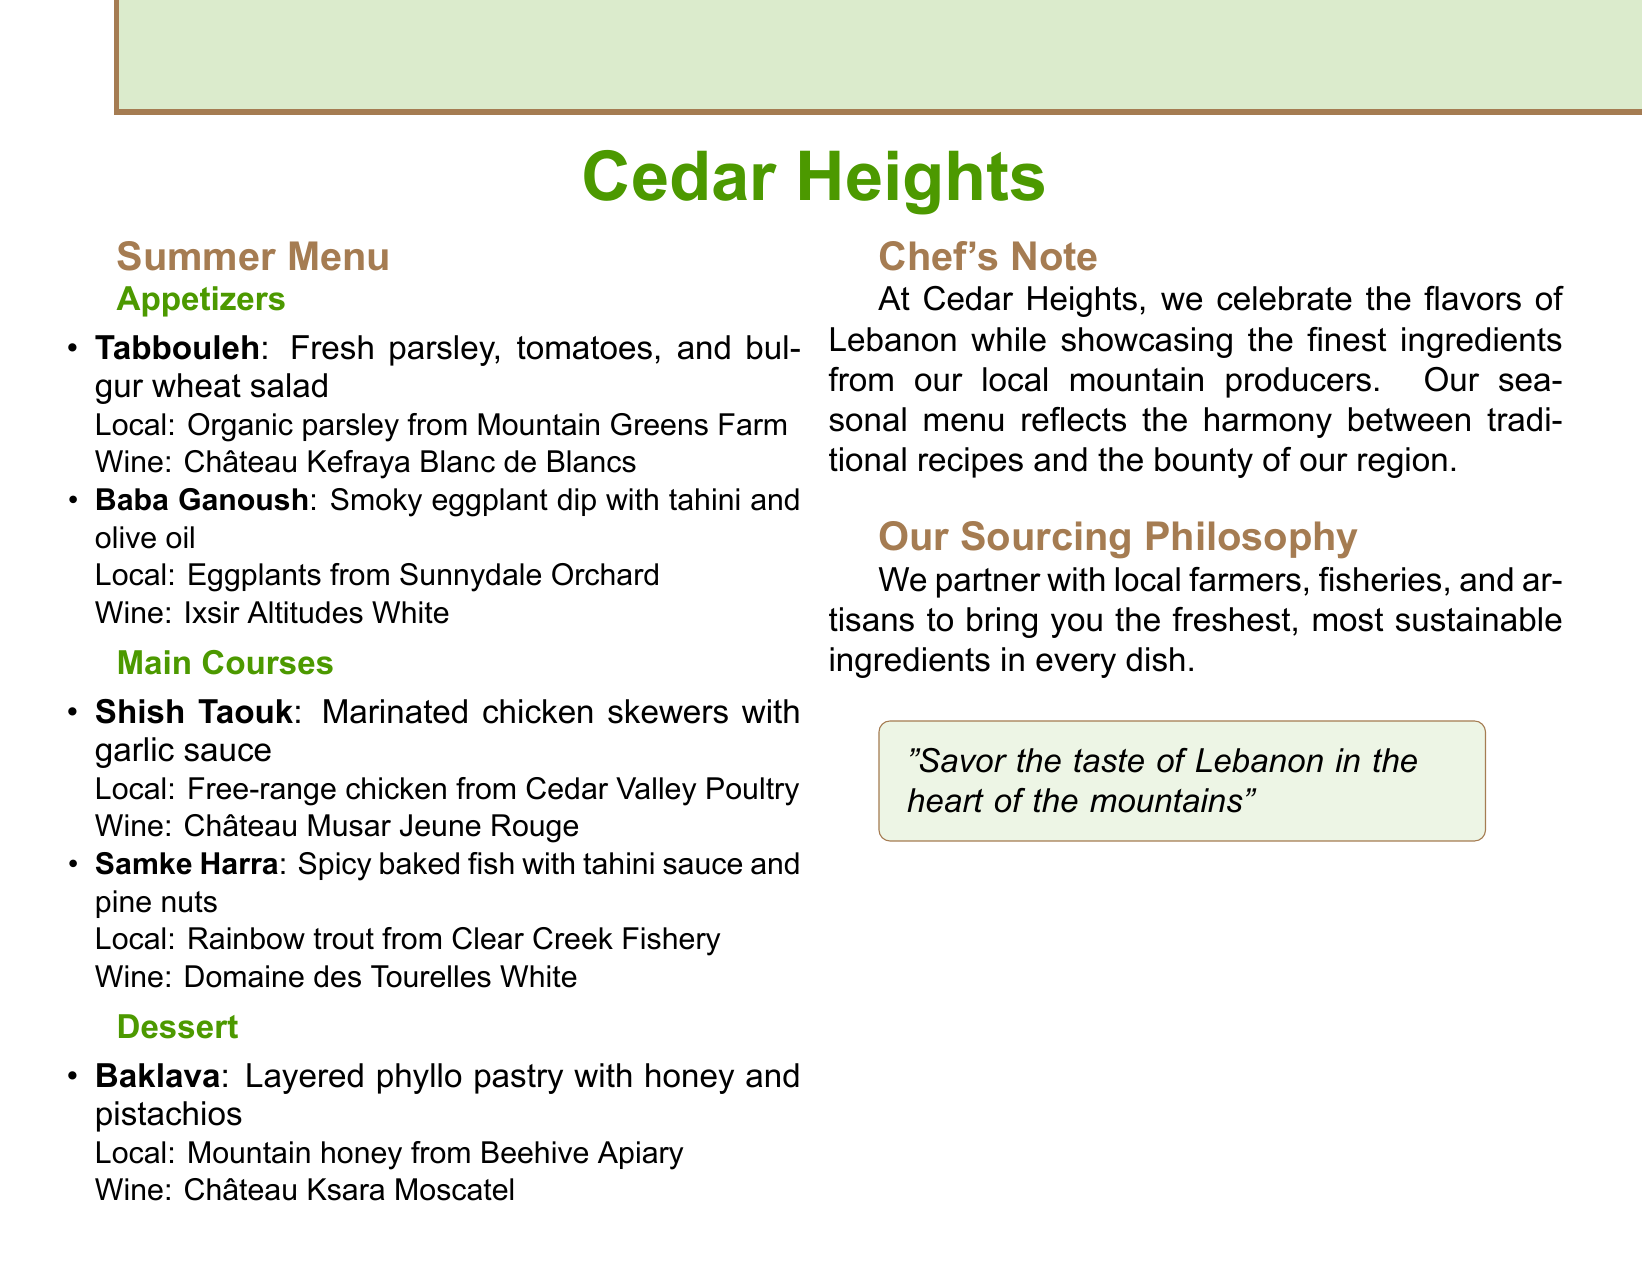what is the name of the restaurant? The name of the restaurant is stated prominently at the top of the document.
Answer: Cedar Heights what type of cuisine is featured in the menu? The document specifies the type of cuisine prominently in the title.
Answer: Lebanese which farm provides the parsley for Tabbouleh? The specific farm providing the parsley is mentioned alongside the dish.
Answer: Mountain Greens Farm what is the wine pairing for Baklava? The wine recommendation for Baklava is given in the dessert section.
Answer: Château Ksara Moscatel how many main courses are listed in the menu? The total number of main courses can be counted in the corresponding section.
Answer: 2 what is the focus of the Chef's Note? The Chef's Note discusses the philosophy behind the menu.
Answer: Flavors of Lebanon which dessert uses honey from a local producer? The dessert that mentions local honey is highlighted in the dessert section.
Answer: Baklava who supplies the chicken for Shish Taouk? The source of the chicken for the dish is specified in the main courses section.
Answer: Cedar Valley Poultry what does the restaurant celebrate according to the sourcing philosophy? The last section details the essence of their sourcing philosophy.
Answer: Freshest ingredients 